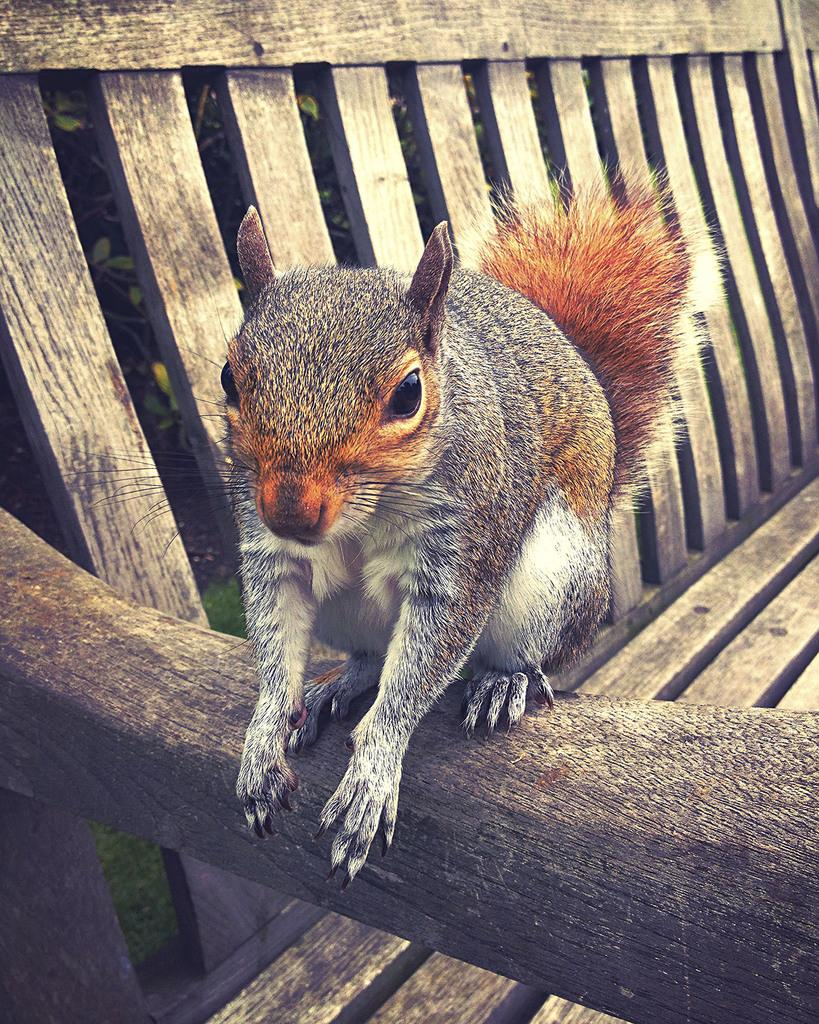What animal is present in the image? There is a squirrel in the image. Where is the squirrel located? The squirrel is on a bench. Can you describe the appearance of the image? The image appears to be edited. What type of linen is draped over the squirrel in the image? There is no linen present in the image, and the squirrel is not covered by any fabric. 